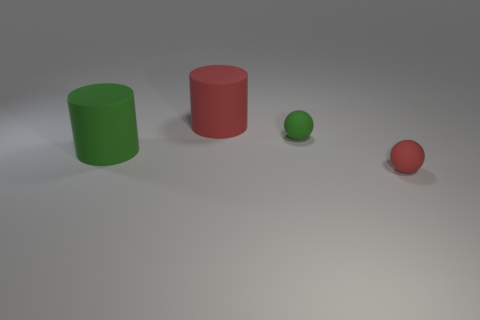How big is the object that is both in front of the small green rubber object and to the left of the red rubber ball?
Offer a terse response. Large. What number of matte things are either purple balls or large cylinders?
Make the answer very short. 2. There is a red matte object on the right side of the big red rubber object; is it the same shape as the green thing that is right of the large red rubber thing?
Give a very brief answer. Yes. Are there any other things that have the same material as the large green object?
Your answer should be very brief. Yes. What size is the matte sphere behind the large green cylinder?
Give a very brief answer. Small. There is a matte object that is in front of the big green matte cylinder; is there a cylinder that is on the right side of it?
Your response must be concise. No. Is the color of the rubber cylinder that is in front of the red cylinder the same as the ball that is behind the red matte ball?
Offer a very short reply. Yes. What is the color of the other rubber ball that is the same size as the red sphere?
Provide a succinct answer. Green. Is the number of tiny green rubber spheres that are in front of the big green rubber object the same as the number of rubber things that are right of the red cylinder?
Provide a succinct answer. No. What is the material of the large object that is behind the big cylinder that is in front of the big red object?
Your answer should be compact. Rubber. 